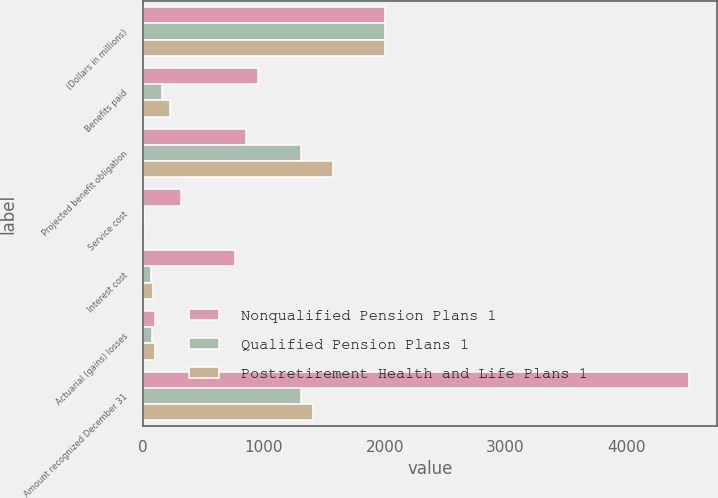Convert chart. <chart><loc_0><loc_0><loc_500><loc_500><stacked_bar_chart><ecel><fcel>(Dollars in millions)<fcel>Benefits paid<fcel>Projected benefit obligation<fcel>Service cost<fcel>Interest cost<fcel>Actuarial (gains) losses<fcel>Amount recognized December 31<nl><fcel>Nonqualified Pension Plans 1<fcel>2007<fcel>953<fcel>857<fcel>316<fcel>761<fcel>103<fcel>4520<nl><fcel>Qualified Pension Plans 1<fcel>2007<fcel>157<fcel>1307<fcel>9<fcel>71<fcel>74<fcel>1305<nl><fcel>Postretirement Health and Life Plans 1<fcel>2007<fcel>225<fcel>1576<fcel>16<fcel>84<fcel>101<fcel>1411<nl></chart> 